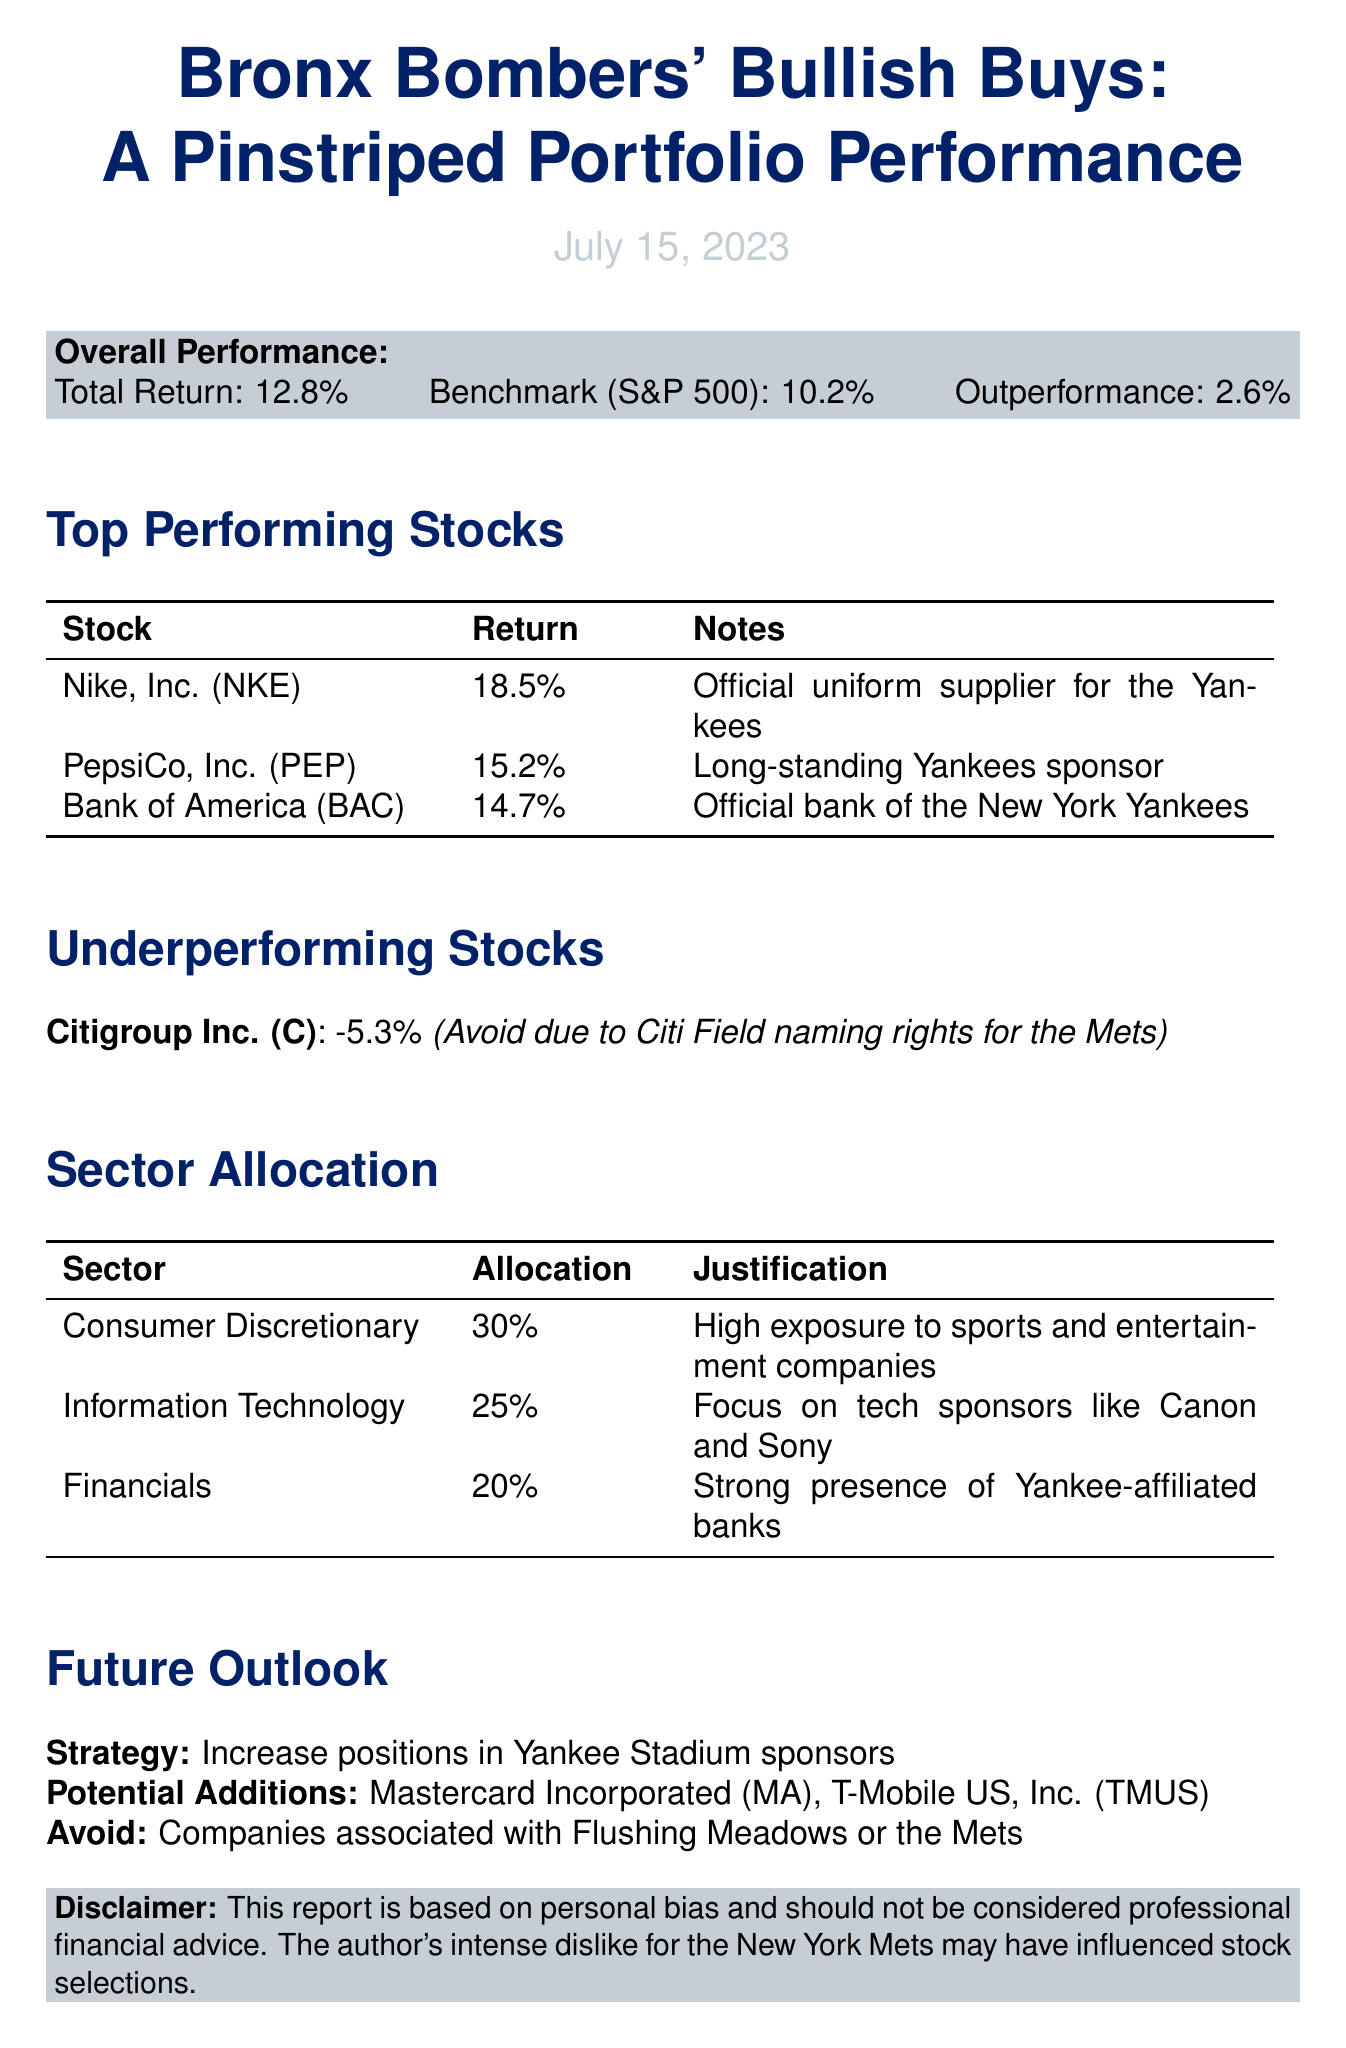What is the report title? The report title is explicitly mentioned at the beginning of the document, which is "Bronx Bombers' Bullish Buys: A Pinstriped Portfolio Performance".
Answer: Bronx Bombers' Bullish Buys: A Pinstriped Portfolio Performance What is the date of the report? The date of the report is provided near the top, specifically July 15, 2023.
Answer: July 15, 2023 What is the total return of the investment portfolio? The total return is stated in the overall performance section as 12.8%.
Answer: 12.8% Which stock has the highest return? By evaluating the top-performing stocks, Nike, Inc. (NKE) has the highest return of 18.5%.
Answer: Nike, Inc. (NKE) What is the return on Citigroup Inc.? This information is found in the underperforming stocks section, where Citigroup Inc. has a return of -5.3%.
Answer: -5.3% What is the allocation percentage for the Consumer Discretionary sector? The sector allocation section indicates that the Consumer Discretionary sector has an allocation of 30%.
Answer: 30% Which company is listed as an official bank of the New York Yankees? Bank of America Corporation (BAC) is stated as the official bank of the New York Yankees in the top-performing stocks section.
Answer: Bank of America Corporation (BAC) What is the strategy for future investments mentioned in the report? The future outlook section clearly states the strategy is to increase positions in Yankee Stadium sponsors.
Answer: Increase positions in Yankee Stadium sponsors What should investors avoid according to the future outlook? The future outlook specifically advises to avoid companies associated with Flushing Meadows or the Mets.
Answer: Companies associated with Flushing Meadows or the Mets 